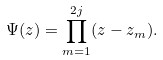Convert formula to latex. <formula><loc_0><loc_0><loc_500><loc_500>\Psi ( z ) = \prod ^ { 2 j } _ { m = 1 } ( z - z _ { m } ) .</formula> 